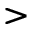Convert formula to latex. <formula><loc_0><loc_0><loc_500><loc_500>></formula> 